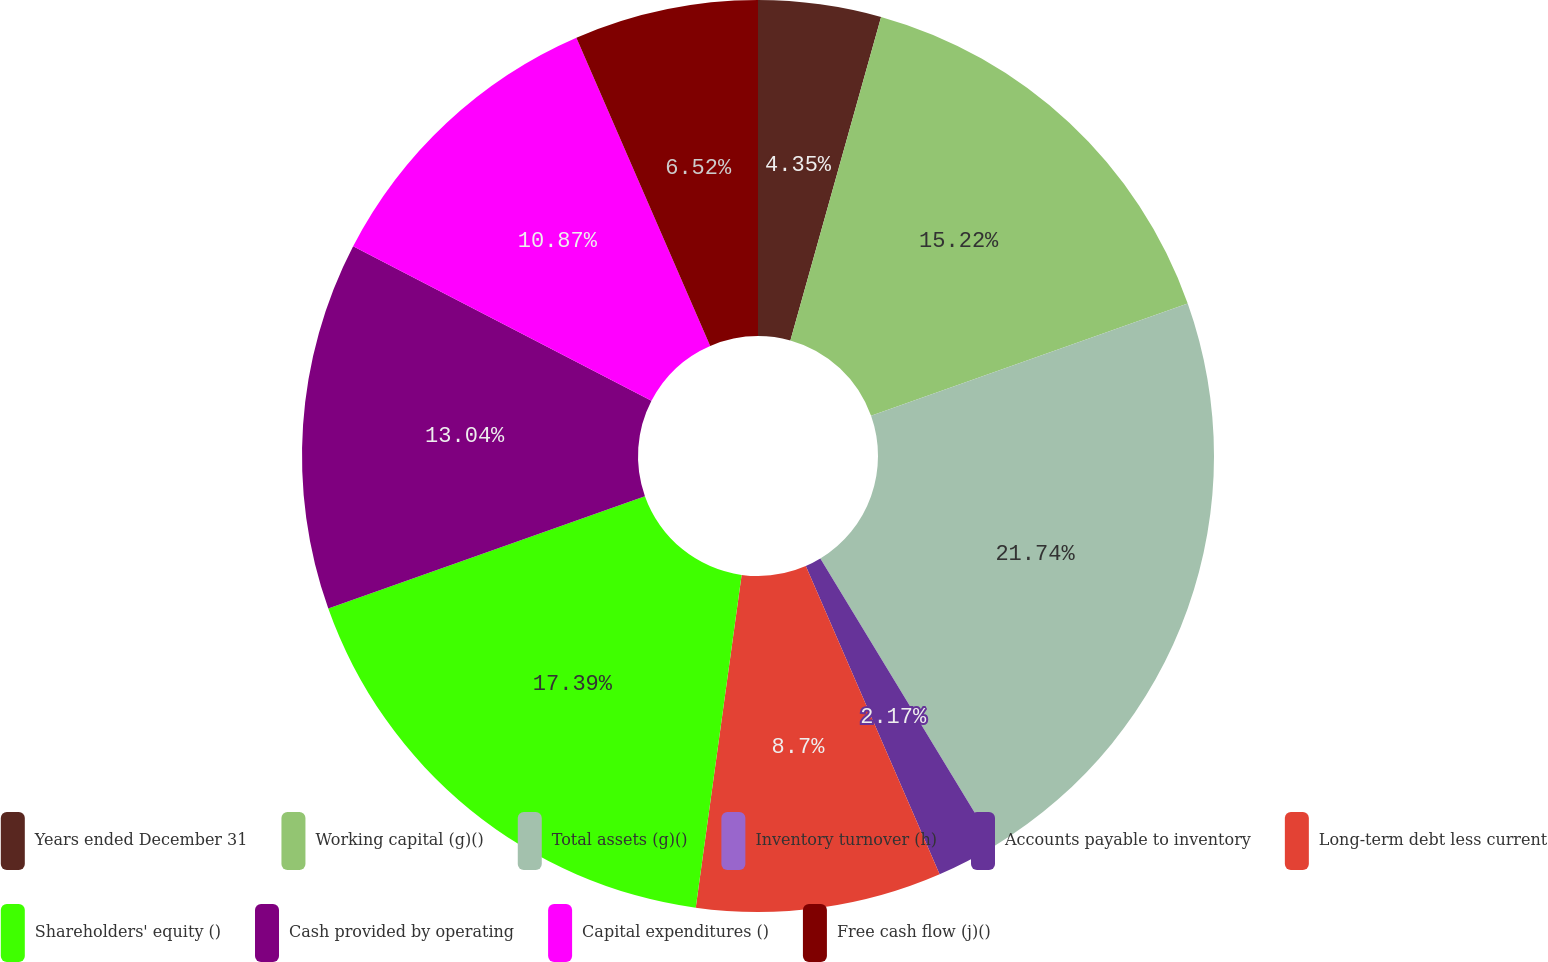Convert chart to OTSL. <chart><loc_0><loc_0><loc_500><loc_500><pie_chart><fcel>Years ended December 31<fcel>Working capital (g)()<fcel>Total assets (g)()<fcel>Inventory turnover (h)<fcel>Accounts payable to inventory<fcel>Long-term debt less current<fcel>Shareholders' equity ()<fcel>Cash provided by operating<fcel>Capital expenditures ()<fcel>Free cash flow (j)()<nl><fcel>4.35%<fcel>15.22%<fcel>21.74%<fcel>0.0%<fcel>2.17%<fcel>8.7%<fcel>17.39%<fcel>13.04%<fcel>10.87%<fcel>6.52%<nl></chart> 